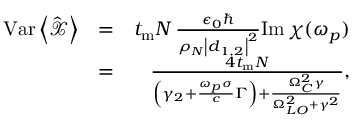<formula> <loc_0><loc_0><loc_500><loc_500>\begin{array} { r l r } { V a r \left < \hat { \mathcal { X } } \right > } & { = } & { t _ { m } N \, \frac { \epsilon _ { 0 } } { \rho _ { N } \left | \boldsymbol d _ { 1 , 2 } \right | ^ { 2 } } I m \, \chi ( \omega _ { p } ) } \\ & { = } & { \frac { 4 t _ { m } N } { \left ( \gamma _ { 2 } + \frac { \omega _ { p } \sigma } { c } \Gamma \right ) + \frac { \Omega _ { C } ^ { 2 } \gamma } { \Omega _ { L O } ^ { 2 } + \gamma ^ { 2 } } } , } \end{array}</formula> 